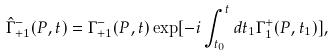<formula> <loc_0><loc_0><loc_500><loc_500>\hat { \Gamma } _ { + 1 } ^ { - } ( P , t ) = \Gamma _ { + 1 } ^ { - } ( P , t ) \exp [ - i \int _ { t _ { 0 } } ^ { t } d t _ { 1 } \Gamma _ { 1 } ^ { + } ( P , t _ { 1 } ) ] ,</formula> 